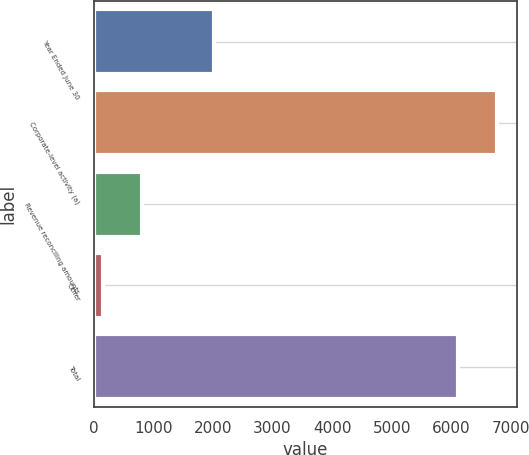Convert chart to OTSL. <chart><loc_0><loc_0><loc_500><loc_500><bar_chart><fcel>Year Ended June 30<fcel>Corporate-level activity (a)<fcel>Revenue reconciling amounts<fcel>Other<fcel>Total<nl><fcel>2013<fcel>6761<fcel>806<fcel>155<fcel>6110<nl></chart> 